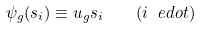Convert formula to latex. <formula><loc_0><loc_0><loc_500><loc_500>\psi _ { g } ( s _ { i } ) \equiv u _ { g } s _ { i } \quad ( i \ e d o t )</formula> 